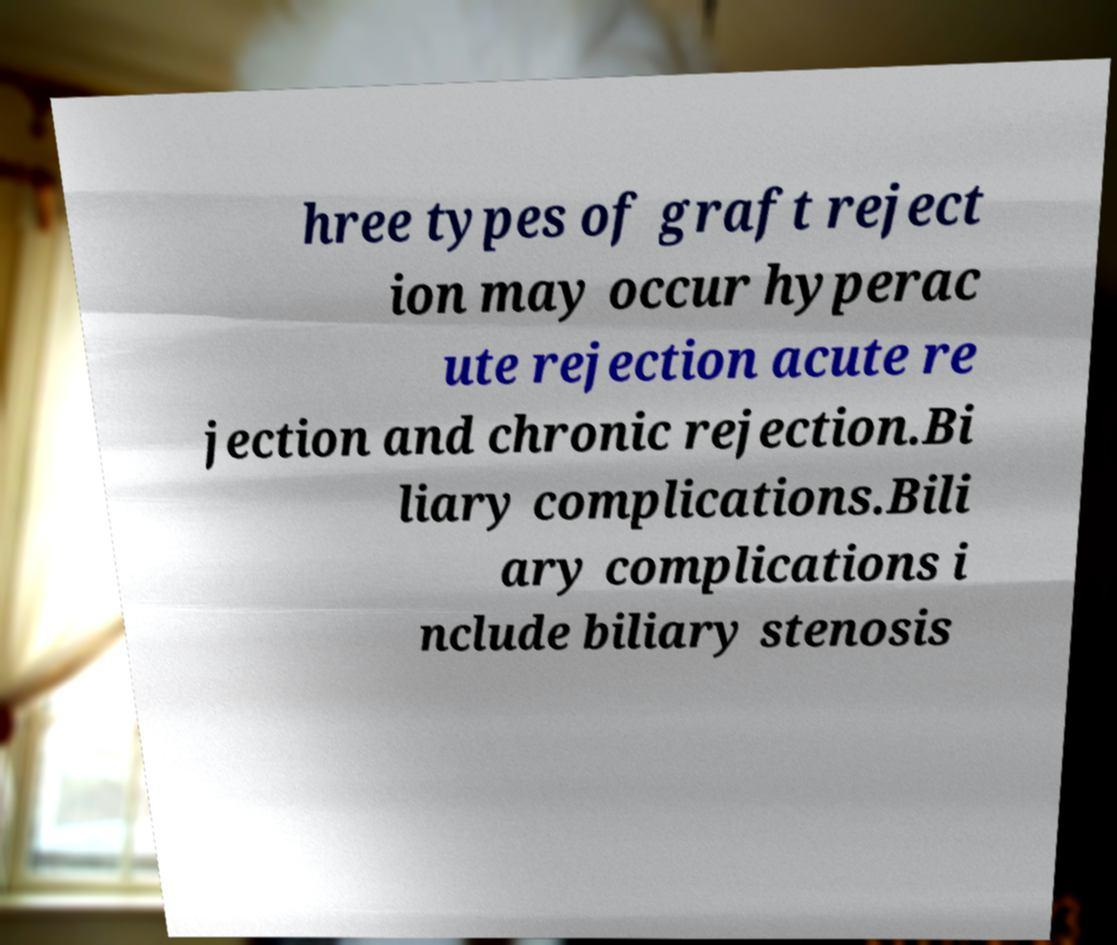I need the written content from this picture converted into text. Can you do that? hree types of graft reject ion may occur hyperac ute rejection acute re jection and chronic rejection.Bi liary complications.Bili ary complications i nclude biliary stenosis 